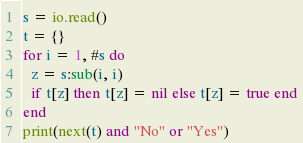Convert code to text. <code><loc_0><loc_0><loc_500><loc_500><_Lua_>s = io.read()
t = {}
for i = 1, #s do
  z = s:sub(i, i)
  if t[z] then t[z] = nil else t[z] = true end
end
print(next(t) and "No" or "Yes")
</code> 